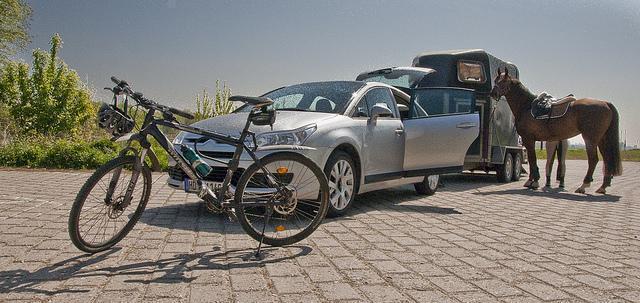What is being used to pull the black trailer?
Indicate the correct response and explain using: 'Answer: answer
Rationale: rationale.'
Options: Dog, men, bike, car. Answer: car.
Rationale: The car is being used to pull it. 